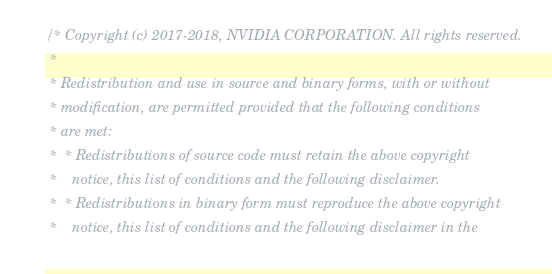<code> <loc_0><loc_0><loc_500><loc_500><_Cuda_>/* Copyright (c) 2017-2018, NVIDIA CORPORATION. All rights reserved.
 *
 * Redistribution and use in source and binary forms, with or without
 * modification, are permitted provided that the following conditions
 * are met:
 *  * Redistributions of source code must retain the above copyright
 *    notice, this list of conditions and the following disclaimer.
 *  * Redistributions in binary form must reproduce the above copyright
 *    notice, this list of conditions and the following disclaimer in the</code> 